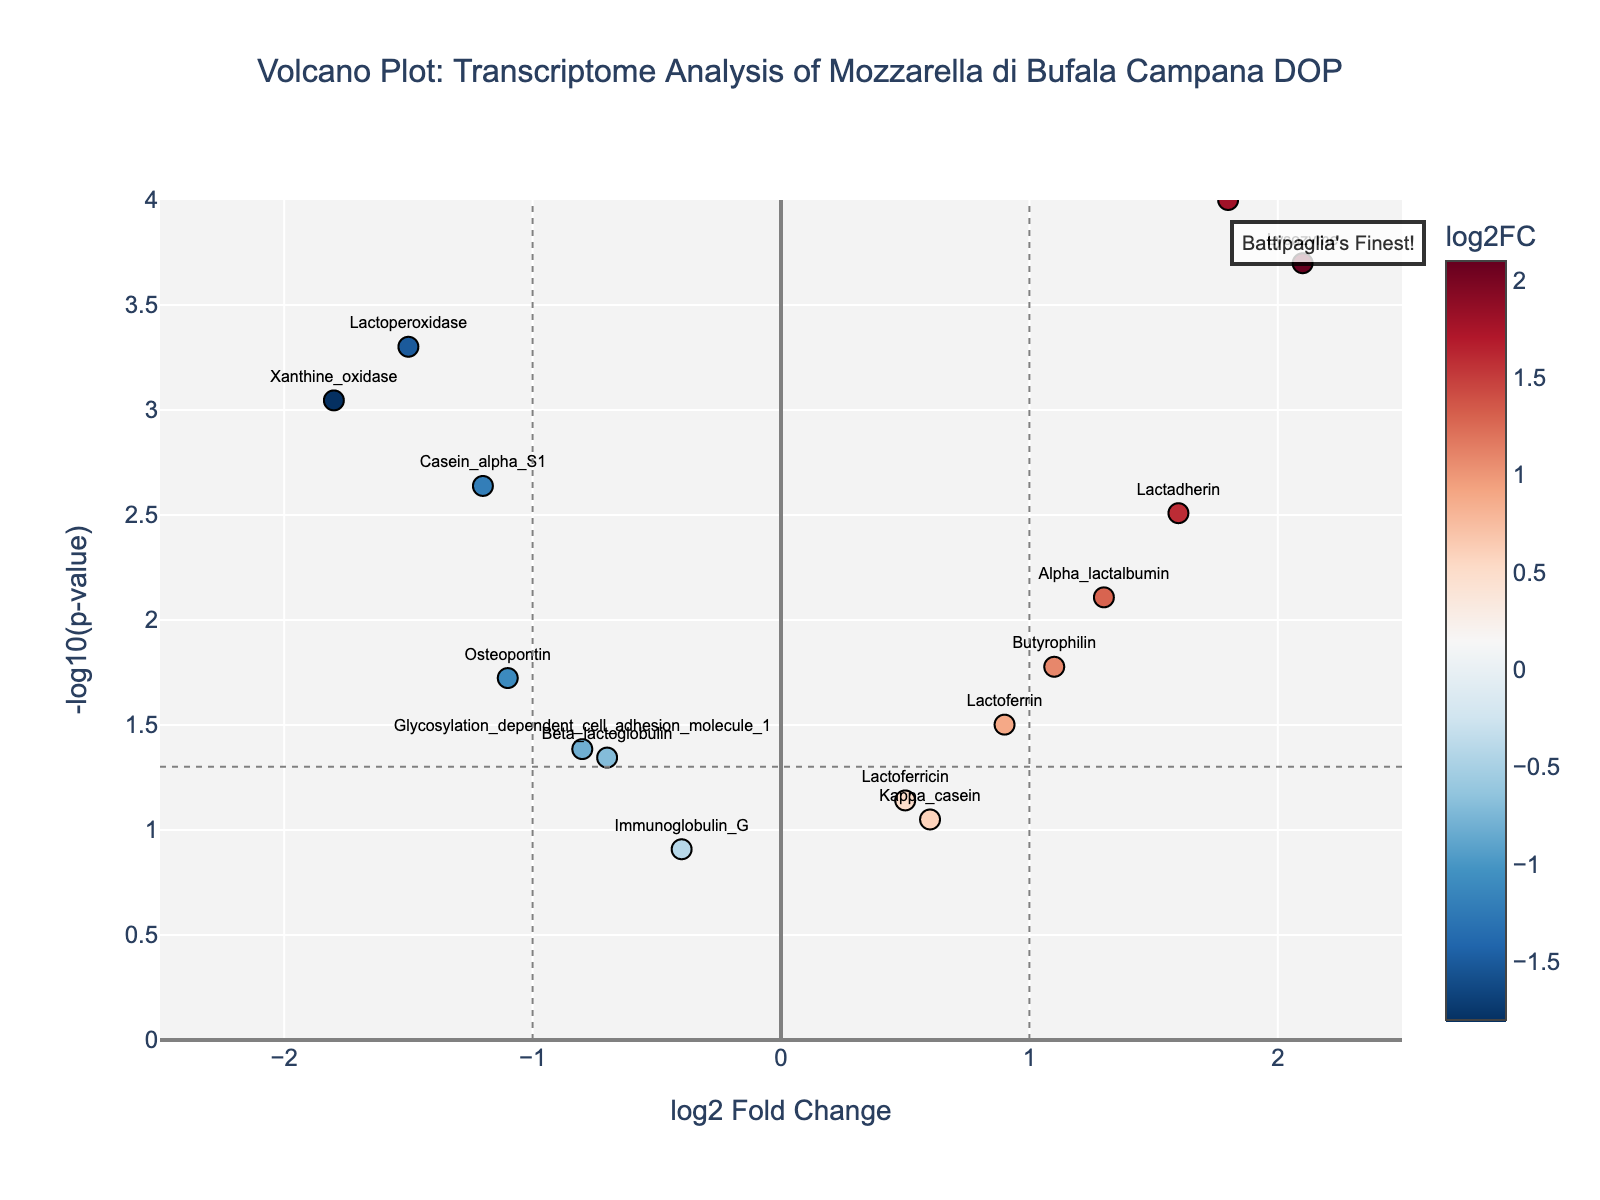What is the title of the plot? The title is displayed at the top of the plot in a larger font size compared to other text and it reads "Volcano Plot: Transcriptome Analysis of Mozzarella di Bufala Campana DOP".
Answer: Volcano Plot: Transcriptome Analysis of Mozzarella di Bufala Campana DOP How many genes have a log2 Fold Change greater than 1? To find this, look at the x-axis where the log2 Fold Change is greater than 1 and count the corresponding data points. There are three data points at (1.8, 4), (2.1, 3.7), and (1.3, 2.1).
Answer: 3 Which gene has the highest -log10(p-value)? Look at the y-axis to find the highest value, then check which data point this corresponds to. The highest value is approximately 4, corresponding to the gene "Casein_beta".
Answer: Casein_beta Which genes are significantly downregulated? To determine this, look for genes with a log2 Fold Change less than -1 and a -log10(p-value) greater than 1.3 (since -log10(0.05) ≈ 1.3). The genes are "Lactoperoxidase" and "Xanthine_oxidase".
Answer: Lactoperoxidase, Xanthine_oxidase What is the log2 Fold Change and -log10(p-value) for the gene "Butyrophilin"? Locate the data point labeled "Butyrophilin" and read off the x and y coordinates. The coordinates are (1.1, 1.8).
Answer: 1.1, 1.8 Which gene has the smallest p-value? The smallest p-value corresponds to the largest -log10(p-value). The gene with the highest -log10(p-value) is "Casein_beta".
Answer: Casein_beta How many genes are not significantly differentially expressed (p-value > 0.05)? Check the y-axis for data points with -log10(p-value) less than 1.3 and count these points. These points are "Kappa_casein", "Immunoglobulin_G", and "Lactoferricin".
Answer: 3 Are there more upregulated or downregulated genes with significant expression changes? Compare the number of points with log2 Fold Change > 1 and -log10(p-value) > 1.3 to those with log2 Fold Change < -1 and -log10(p-value) > 1.3. There are three upregulated (log2 Fold Change > 1) and two downregulated (log2 Fold Change < -1).
Answer: More upregulated (3 vs 2) Which gene shows the highest log2 Fold Change? Find the data point with the highest x value. The gene with the highest log2 Fold Change value is "Lysozyme" at 2.1.
Answer: Lysozyme 